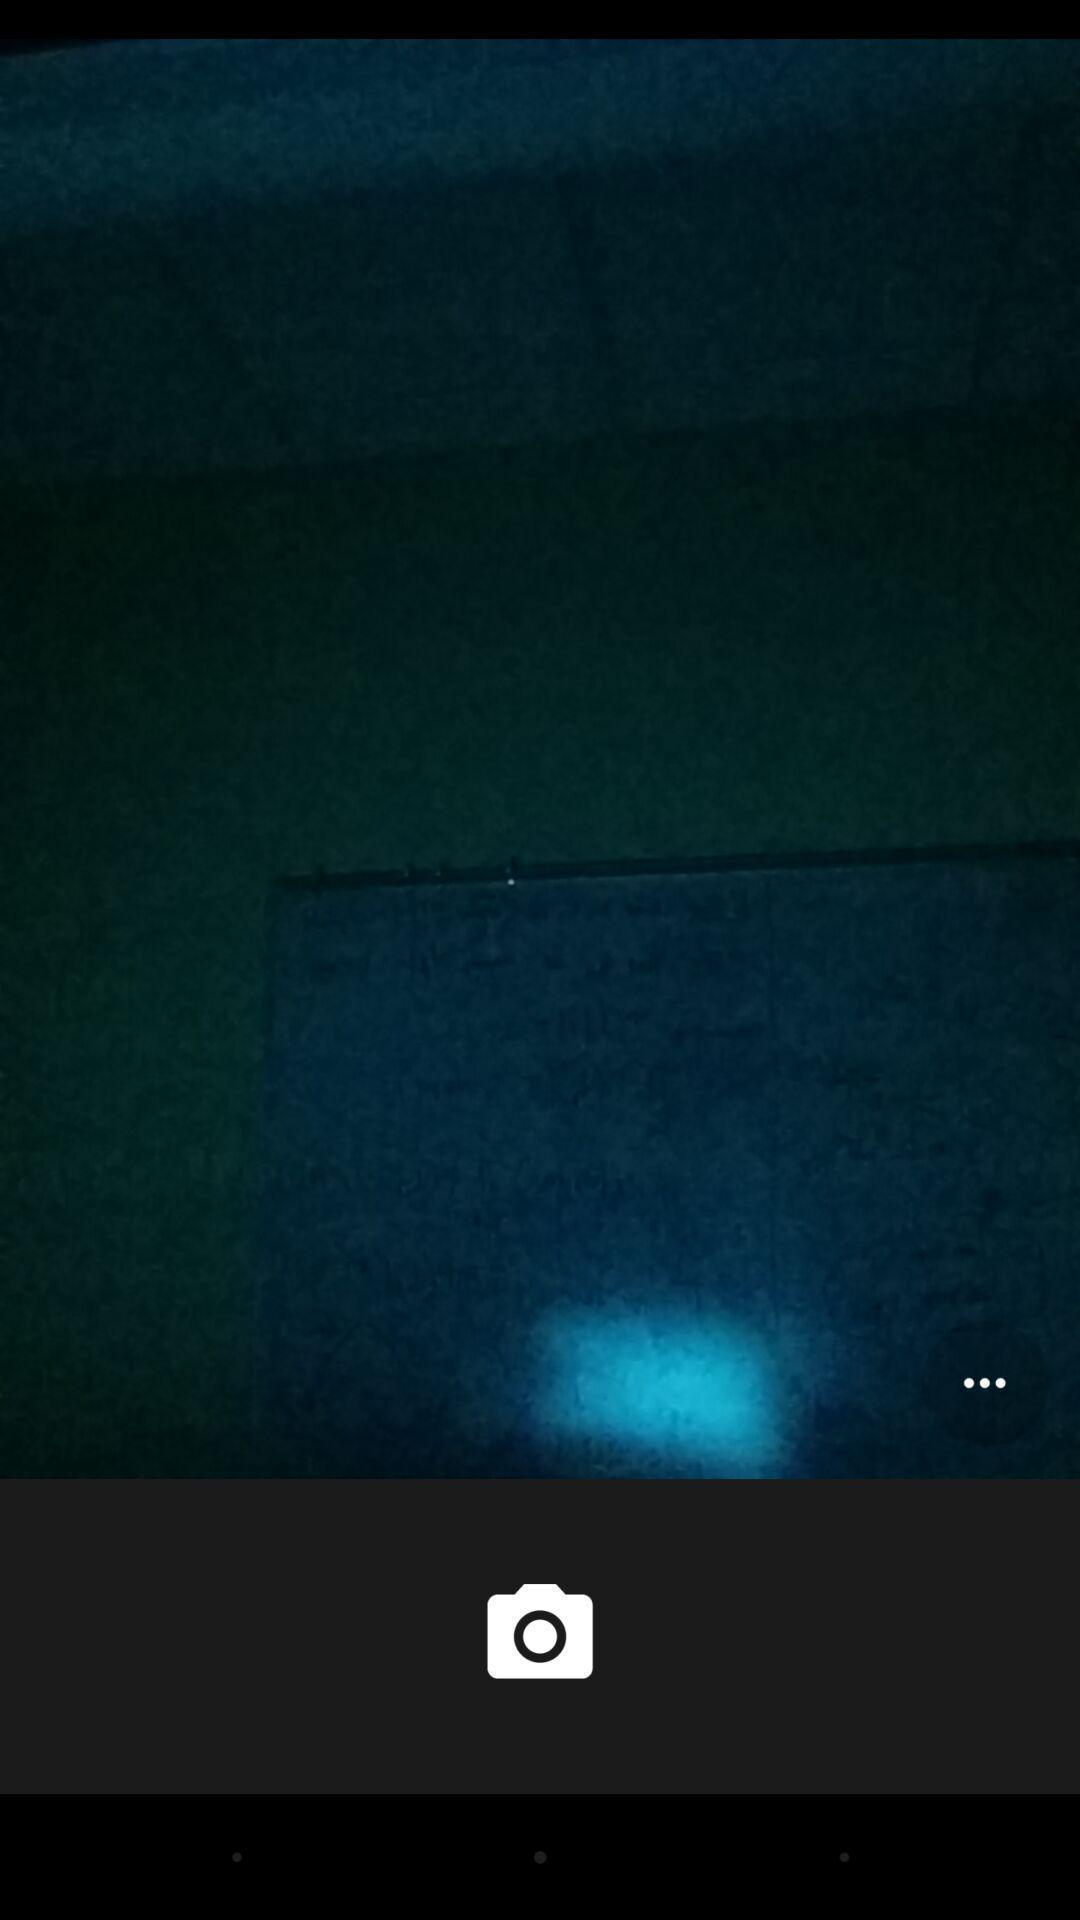Describe this image in words. Page showing the user interface of a camera app. 